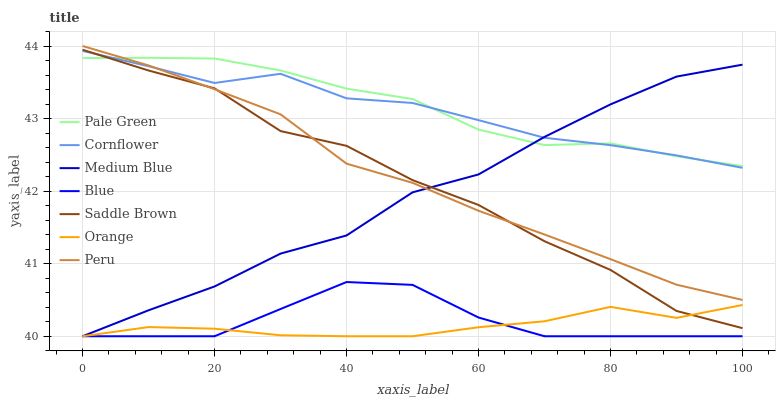Does Orange have the minimum area under the curve?
Answer yes or no. Yes. Does Pale Green have the maximum area under the curve?
Answer yes or no. Yes. Does Cornflower have the minimum area under the curve?
Answer yes or no. No. Does Cornflower have the maximum area under the curve?
Answer yes or no. No. Is Peru the smoothest?
Answer yes or no. Yes. Is Saddle Brown the roughest?
Answer yes or no. Yes. Is Cornflower the smoothest?
Answer yes or no. No. Is Cornflower the roughest?
Answer yes or no. No. Does Blue have the lowest value?
Answer yes or no. Yes. Does Cornflower have the lowest value?
Answer yes or no. No. Does Peru have the highest value?
Answer yes or no. Yes. Does Cornflower have the highest value?
Answer yes or no. No. Is Blue less than Cornflower?
Answer yes or no. Yes. Is Cornflower greater than Blue?
Answer yes or no. Yes. Does Cornflower intersect Pale Green?
Answer yes or no. Yes. Is Cornflower less than Pale Green?
Answer yes or no. No. Is Cornflower greater than Pale Green?
Answer yes or no. No. Does Blue intersect Cornflower?
Answer yes or no. No. 